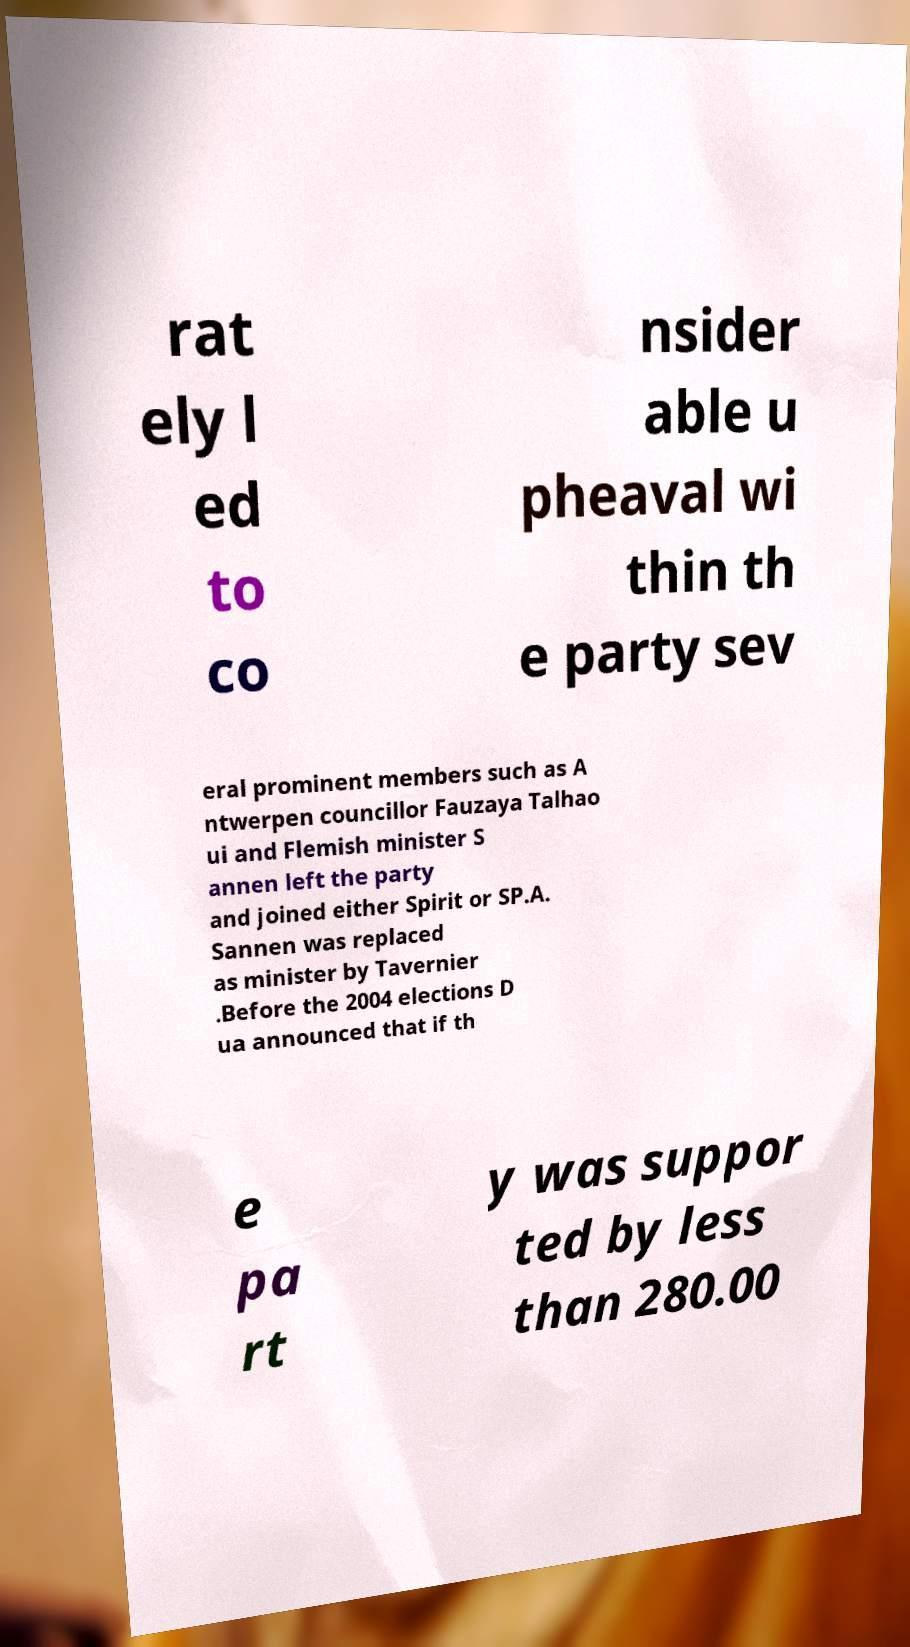For documentation purposes, I need the text within this image transcribed. Could you provide that? rat ely l ed to co nsider able u pheaval wi thin th e party sev eral prominent members such as A ntwerpen councillor Fauzaya Talhao ui and Flemish minister S annen left the party and joined either Spirit or SP.A. Sannen was replaced as minister by Tavernier .Before the 2004 elections D ua announced that if th e pa rt y was suppor ted by less than 280.00 